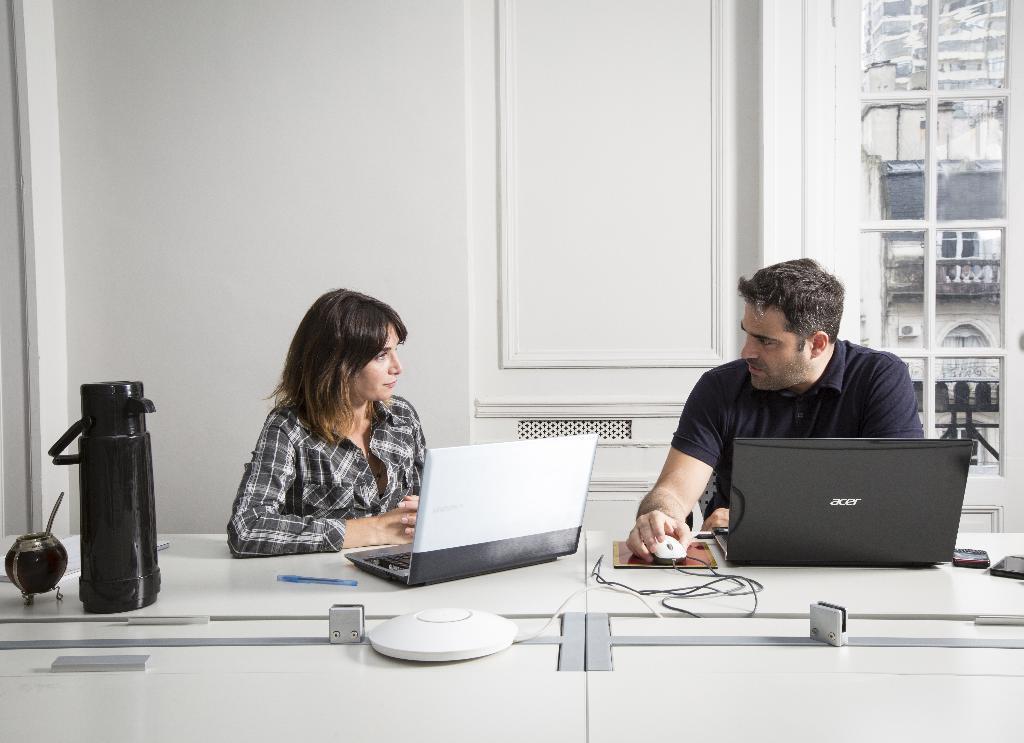Can you describe this image briefly? in the picture there is a room in that room there is a man and woman sitting on a chair table in front of them on the table there are many things such as laptops with a mouse cables mobile phones pens and a flask. 